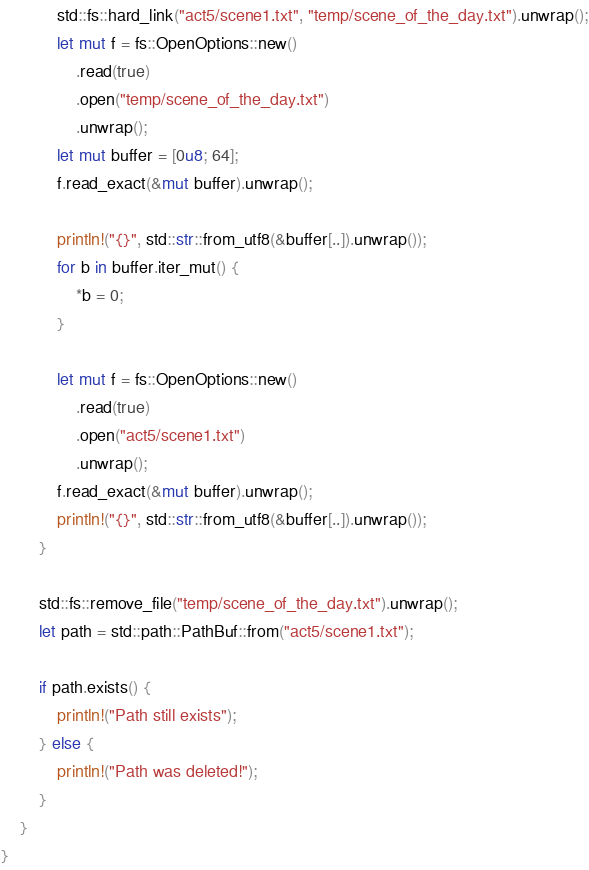Convert code to text. <code><loc_0><loc_0><loc_500><loc_500><_Rust_>            std::fs::hard_link("act5/scene1.txt", "temp/scene_of_the_day.txt").unwrap();
            let mut f = fs::OpenOptions::new()
                .read(true)
                .open("temp/scene_of_the_day.txt")
                .unwrap();
            let mut buffer = [0u8; 64];
            f.read_exact(&mut buffer).unwrap();

            println!("{}", std::str::from_utf8(&buffer[..]).unwrap());
            for b in buffer.iter_mut() {
                *b = 0;
            }

            let mut f = fs::OpenOptions::new()
                .read(true)
                .open("act5/scene1.txt")
                .unwrap();
            f.read_exact(&mut buffer).unwrap();
            println!("{}", std::str::from_utf8(&buffer[..]).unwrap());
        }

        std::fs::remove_file("temp/scene_of_the_day.txt").unwrap();
        let path = std::path::PathBuf::from("act5/scene1.txt");

        if path.exists() {
            println!("Path still exists");
        } else {
            println!("Path was deleted!");
        }
    }
}
</code> 